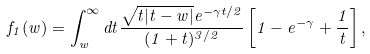Convert formula to latex. <formula><loc_0><loc_0><loc_500><loc_500>f _ { 1 } ( w ) = \int _ { w } ^ { \infty } d t \frac { \sqrt { t | t - w | } e ^ { - \gamma t / 2 } } { ( 1 + t ) ^ { 3 / 2 } } \left [ 1 - e ^ { - \gamma } + \frac { 1 } { t } \right ] ,</formula> 